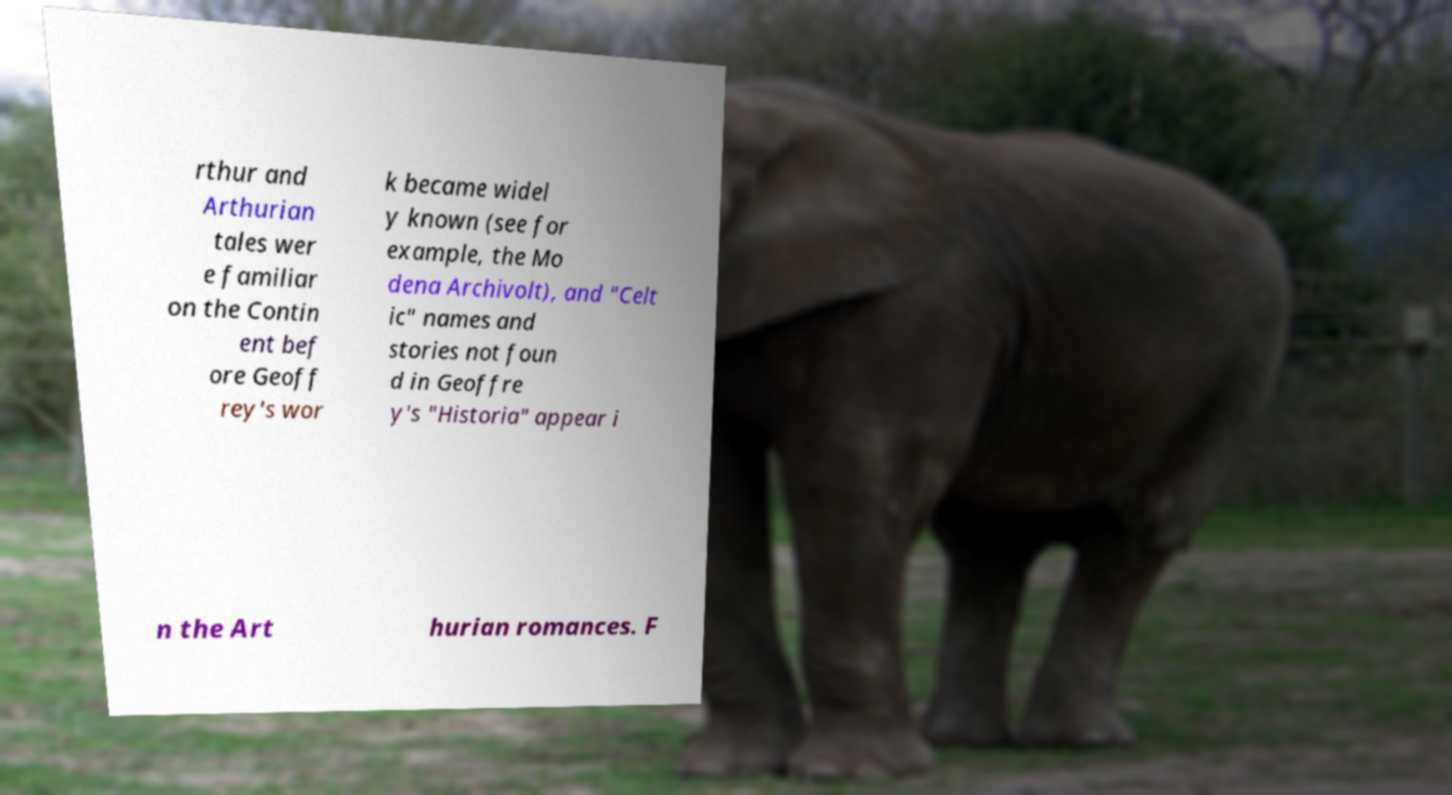Could you extract and type out the text from this image? rthur and Arthurian tales wer e familiar on the Contin ent bef ore Geoff rey's wor k became widel y known (see for example, the Mo dena Archivolt), and "Celt ic" names and stories not foun d in Geoffre y's "Historia" appear i n the Art hurian romances. F 